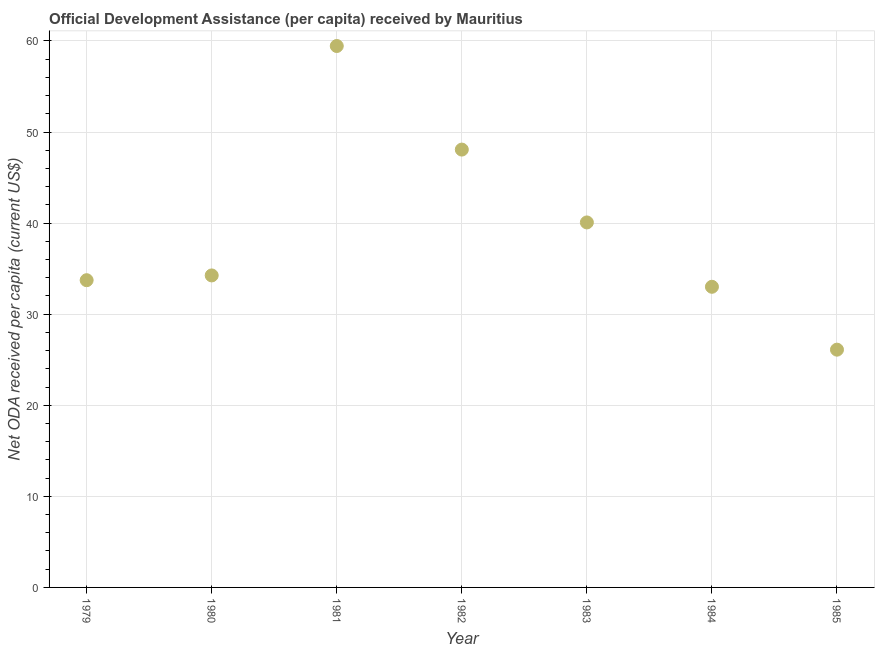What is the net oda received per capita in 1981?
Keep it short and to the point. 59.44. Across all years, what is the maximum net oda received per capita?
Provide a succinct answer. 59.44. Across all years, what is the minimum net oda received per capita?
Your answer should be compact. 26.1. In which year was the net oda received per capita maximum?
Provide a short and direct response. 1981. What is the sum of the net oda received per capita?
Your answer should be compact. 274.68. What is the difference between the net oda received per capita in 1980 and 1981?
Keep it short and to the point. -25.19. What is the average net oda received per capita per year?
Ensure brevity in your answer.  39.24. What is the median net oda received per capita?
Offer a terse response. 34.25. What is the ratio of the net oda received per capita in 1982 to that in 1983?
Keep it short and to the point. 1.2. What is the difference between the highest and the second highest net oda received per capita?
Offer a very short reply. 11.37. Is the sum of the net oda received per capita in 1983 and 1984 greater than the maximum net oda received per capita across all years?
Offer a very short reply. Yes. What is the difference between the highest and the lowest net oda received per capita?
Keep it short and to the point. 33.34. How many dotlines are there?
Make the answer very short. 1. How many years are there in the graph?
Your answer should be very brief. 7. Are the values on the major ticks of Y-axis written in scientific E-notation?
Keep it short and to the point. No. Does the graph contain any zero values?
Keep it short and to the point. No. What is the title of the graph?
Offer a very short reply. Official Development Assistance (per capita) received by Mauritius. What is the label or title of the Y-axis?
Your answer should be very brief. Net ODA received per capita (current US$). What is the Net ODA received per capita (current US$) in 1979?
Offer a very short reply. 33.73. What is the Net ODA received per capita (current US$) in 1980?
Provide a short and direct response. 34.25. What is the Net ODA received per capita (current US$) in 1981?
Offer a very short reply. 59.44. What is the Net ODA received per capita (current US$) in 1982?
Offer a terse response. 48.07. What is the Net ODA received per capita (current US$) in 1983?
Keep it short and to the point. 40.07. What is the Net ODA received per capita (current US$) in 1984?
Offer a very short reply. 33.01. What is the Net ODA received per capita (current US$) in 1985?
Your response must be concise. 26.1. What is the difference between the Net ODA received per capita (current US$) in 1979 and 1980?
Offer a terse response. -0.52. What is the difference between the Net ODA received per capita (current US$) in 1979 and 1981?
Ensure brevity in your answer.  -25.71. What is the difference between the Net ODA received per capita (current US$) in 1979 and 1982?
Give a very brief answer. -14.34. What is the difference between the Net ODA received per capita (current US$) in 1979 and 1983?
Your answer should be compact. -6.34. What is the difference between the Net ODA received per capita (current US$) in 1979 and 1984?
Ensure brevity in your answer.  0.72. What is the difference between the Net ODA received per capita (current US$) in 1979 and 1985?
Keep it short and to the point. 7.63. What is the difference between the Net ODA received per capita (current US$) in 1980 and 1981?
Provide a short and direct response. -25.19. What is the difference between the Net ODA received per capita (current US$) in 1980 and 1982?
Your answer should be compact. -13.82. What is the difference between the Net ODA received per capita (current US$) in 1980 and 1983?
Keep it short and to the point. -5.82. What is the difference between the Net ODA received per capita (current US$) in 1980 and 1984?
Offer a terse response. 1.25. What is the difference between the Net ODA received per capita (current US$) in 1980 and 1985?
Give a very brief answer. 8.15. What is the difference between the Net ODA received per capita (current US$) in 1981 and 1982?
Your answer should be very brief. 11.37. What is the difference between the Net ODA received per capita (current US$) in 1981 and 1983?
Offer a terse response. 19.37. What is the difference between the Net ODA received per capita (current US$) in 1981 and 1984?
Your answer should be very brief. 26.43. What is the difference between the Net ODA received per capita (current US$) in 1981 and 1985?
Your answer should be very brief. 33.34. What is the difference between the Net ODA received per capita (current US$) in 1982 and 1983?
Provide a succinct answer. 8. What is the difference between the Net ODA received per capita (current US$) in 1982 and 1984?
Provide a succinct answer. 15.06. What is the difference between the Net ODA received per capita (current US$) in 1982 and 1985?
Your answer should be compact. 21.97. What is the difference between the Net ODA received per capita (current US$) in 1983 and 1984?
Provide a short and direct response. 7.07. What is the difference between the Net ODA received per capita (current US$) in 1983 and 1985?
Provide a short and direct response. 13.97. What is the difference between the Net ODA received per capita (current US$) in 1984 and 1985?
Provide a short and direct response. 6.9. What is the ratio of the Net ODA received per capita (current US$) in 1979 to that in 1980?
Give a very brief answer. 0.98. What is the ratio of the Net ODA received per capita (current US$) in 1979 to that in 1981?
Give a very brief answer. 0.57. What is the ratio of the Net ODA received per capita (current US$) in 1979 to that in 1982?
Offer a terse response. 0.7. What is the ratio of the Net ODA received per capita (current US$) in 1979 to that in 1983?
Offer a terse response. 0.84. What is the ratio of the Net ODA received per capita (current US$) in 1979 to that in 1984?
Keep it short and to the point. 1.02. What is the ratio of the Net ODA received per capita (current US$) in 1979 to that in 1985?
Provide a short and direct response. 1.29. What is the ratio of the Net ODA received per capita (current US$) in 1980 to that in 1981?
Provide a succinct answer. 0.58. What is the ratio of the Net ODA received per capita (current US$) in 1980 to that in 1982?
Ensure brevity in your answer.  0.71. What is the ratio of the Net ODA received per capita (current US$) in 1980 to that in 1983?
Offer a very short reply. 0.85. What is the ratio of the Net ODA received per capita (current US$) in 1980 to that in 1984?
Your response must be concise. 1.04. What is the ratio of the Net ODA received per capita (current US$) in 1980 to that in 1985?
Provide a succinct answer. 1.31. What is the ratio of the Net ODA received per capita (current US$) in 1981 to that in 1982?
Provide a succinct answer. 1.24. What is the ratio of the Net ODA received per capita (current US$) in 1981 to that in 1983?
Make the answer very short. 1.48. What is the ratio of the Net ODA received per capita (current US$) in 1981 to that in 1984?
Your response must be concise. 1.8. What is the ratio of the Net ODA received per capita (current US$) in 1981 to that in 1985?
Provide a short and direct response. 2.28. What is the ratio of the Net ODA received per capita (current US$) in 1982 to that in 1984?
Make the answer very short. 1.46. What is the ratio of the Net ODA received per capita (current US$) in 1982 to that in 1985?
Make the answer very short. 1.84. What is the ratio of the Net ODA received per capita (current US$) in 1983 to that in 1984?
Your answer should be very brief. 1.21. What is the ratio of the Net ODA received per capita (current US$) in 1983 to that in 1985?
Your answer should be compact. 1.53. What is the ratio of the Net ODA received per capita (current US$) in 1984 to that in 1985?
Make the answer very short. 1.26. 